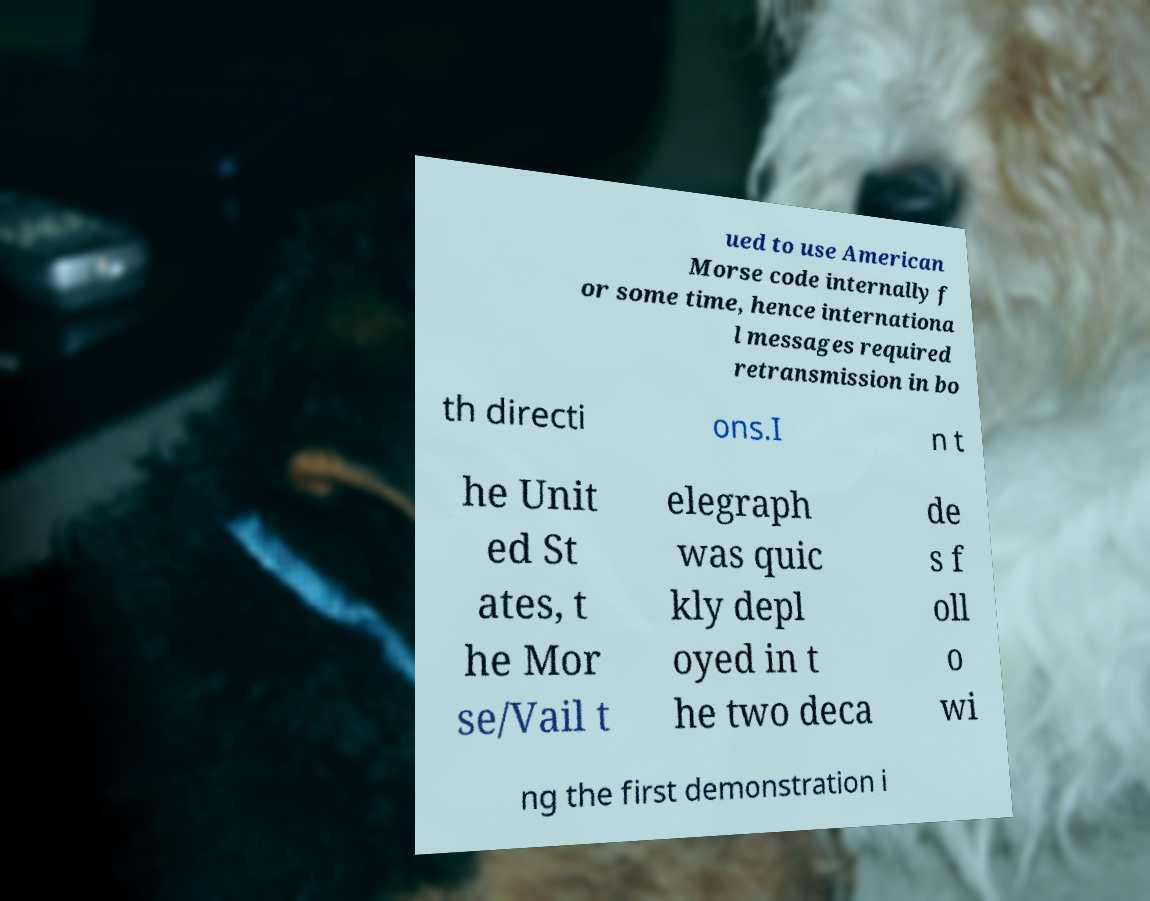For documentation purposes, I need the text within this image transcribed. Could you provide that? ued to use American Morse code internally f or some time, hence internationa l messages required retransmission in bo th directi ons.I n t he Unit ed St ates, t he Mor se/Vail t elegraph was quic kly depl oyed in t he two deca de s f oll o wi ng the first demonstration i 